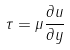Convert formula to latex. <formula><loc_0><loc_0><loc_500><loc_500>\tau = \mu \frac { \partial u } { \partial y }</formula> 